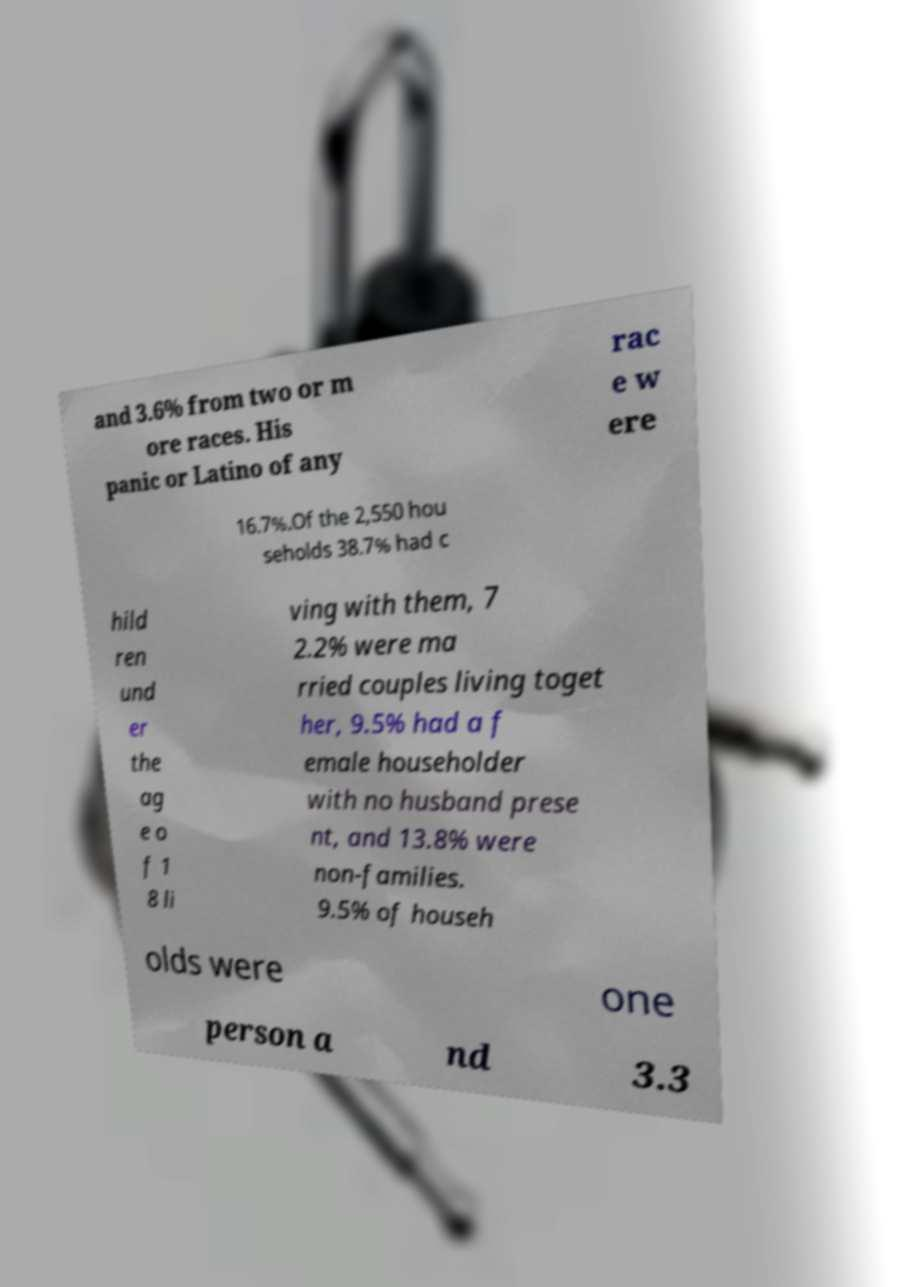Could you assist in decoding the text presented in this image and type it out clearly? and 3.6% from two or m ore races. His panic or Latino of any rac e w ere 16.7%.Of the 2,550 hou seholds 38.7% had c hild ren und er the ag e o f 1 8 li ving with them, 7 2.2% were ma rried couples living toget her, 9.5% had a f emale householder with no husband prese nt, and 13.8% were non-families. 9.5% of househ olds were one person a nd 3.3 